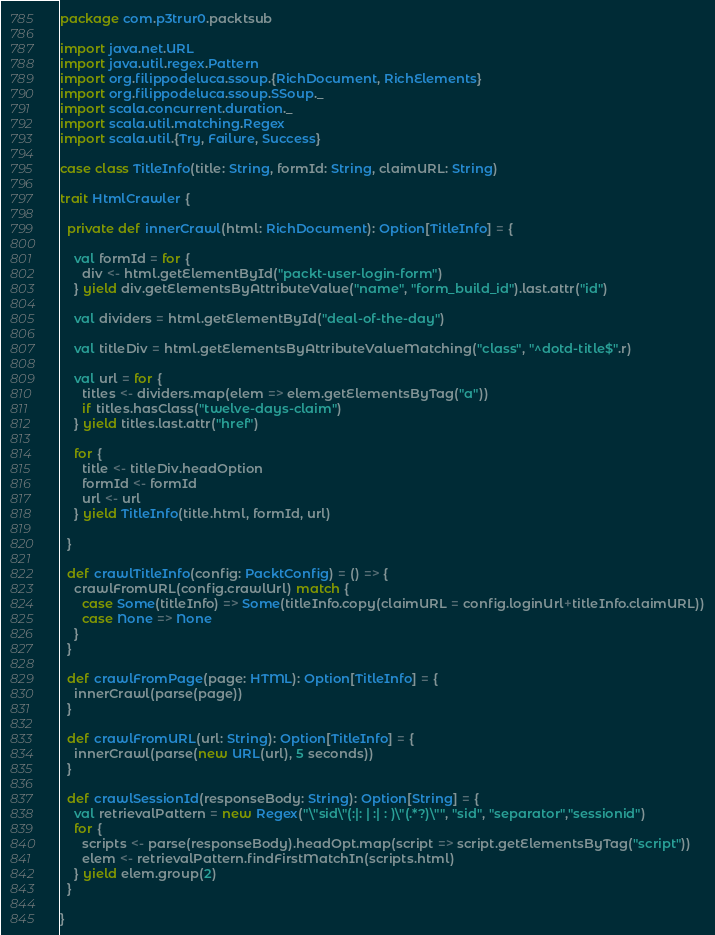Convert code to text. <code><loc_0><loc_0><loc_500><loc_500><_Scala_>package com.p3trur0.packtsub

import java.net.URL
import java.util.regex.Pattern
import org.filippodeluca.ssoup.{RichDocument, RichElements}
import org.filippodeluca.ssoup.SSoup._
import scala.concurrent.duration._
import scala.util.matching.Regex
import scala.util.{Try, Failure, Success}

case class TitleInfo(title: String, formId: String, claimURL: String)

trait HtmlCrawler {

  private def innerCrawl(html: RichDocument): Option[TitleInfo] = {
   
    val formId = for {
      div <- html.getElementById("packt-user-login-form")
    } yield div.getElementsByAttributeValue("name", "form_build_id").last.attr("id")

    val dividers = html.getElementById("deal-of-the-day")

    val titleDiv = html.getElementsByAttributeValueMatching("class", "^dotd-title$".r)
    
    val url = for {
      titles <- dividers.map(elem => elem.getElementsByTag("a"))
      if titles.hasClass("twelve-days-claim")
    } yield titles.last.attr("href")

    for {
      title <- titleDiv.headOption
      formId <- formId
      url <- url
    } yield TitleInfo(title.html, formId, url)

  }
  
  def crawlTitleInfo(config: PacktConfig) = () => {
    crawlFromURL(config.crawlUrl) match {
      case Some(titleInfo) => Some(titleInfo.copy(claimURL = config.loginUrl+titleInfo.claimURL))
      case None => None
    }
  }

  def crawlFromPage(page: HTML): Option[TitleInfo] = {
    innerCrawl(parse(page))
  }

  def crawlFromURL(url: String): Option[TitleInfo] = {
    innerCrawl(parse(new URL(url), 5 seconds))
  }

  def crawlSessionId(responseBody: String): Option[String] = {
    val retrievalPattern = new Regex("\"sid\"(:|: | :| : )\"(.*?)\"", "sid", "separator","sessionid")
    for {
      scripts <- parse(responseBody).headOpt.map(script => script.getElementsByTag("script"))
      elem <- retrievalPattern.findFirstMatchIn(scripts.html)
    } yield elem.group(2)
  }

}</code> 